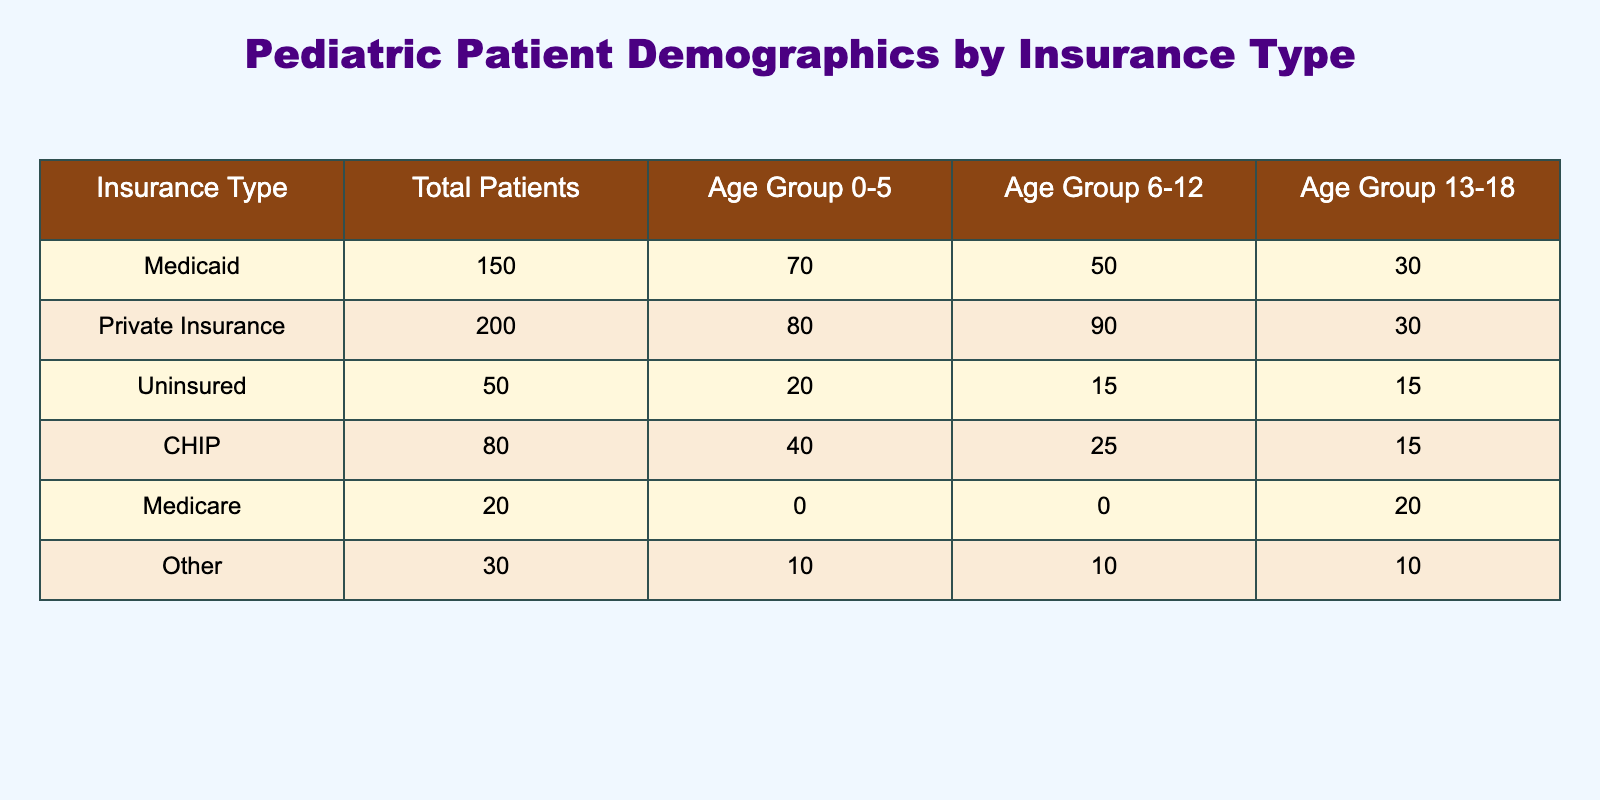What is the total number of patients with Private Insurance? The table shows the total number of patients for each insurance type. For Private Insurance, the total is listed directly as 200.
Answer: 200 Which age group has the highest number of patients insured by Medicaid? By examining the age group columns, Medicaid has 70 patients in the 0-5 age group, 50 in the 6-12 group, and 30 in the 13-18 group. The 0-5 age group has the highest number at 70.
Answer: 0-5 How many total patients are uninsured or have CHIP? To find this, we sum the total patients for both Uninsured (50) and CHIP (80). The calculation is 50 + 80 = 130.
Answer: 130 Is the number of patients with Medicare higher than those with Other insurance types? The table shows Medicare has 20 patients while Other has 30 patients. Therefore, the number of patients with Medicare (20) is not higher than Other (30).
Answer: No What is the average number of patients across all age groups for those insured by Private Insurance? Private Insurance has 80 patients in the 0-5 age group, 90 in 6-12, and 30 in 13-18. The total number across age groups is 80 + 90 + 30 = 200. To find the average, divide by the number of age groups (3): 200/3 ≈ 66.67.
Answer: 66.67 Which insurance type has the least number of patients in the 6-12 age group? Looking at the 6-12 age group, Medicaid has 50, Private Insurance has 90, Uninsured has 15, CHIP has 25, Medicare has 0, and Other has 10. Medicare has the lowest at 0 patients.
Answer: Medicare What percentage of the total patients are covered by Medicaid? To calculate this, first sum the total patients: 150 (Medicaid) + 200 (Private Insurance) + 50 (Uninsured) + 80 (CHIP) + 20 (Medicare) + 30 (Other) = 530. Then divide the number of Medicaid patients (150) by the total and multiply by 100: (150/530) * 100 ≈ 28.30%.
Answer: 28.30% Which age group accounts for the highest number of uninsured patients? For Uninsured patients, the age groups are 20 (0-5), 15 (6-12), and 15 (13-18). The 0-5 age group has the highest number with 20 patients.
Answer: 0-5 What is the total number of patients across all age groups with Other insurance? According to the table, Other has 10 patients each in the age groups 0-5, 6-12, and 13-18. Therefore, the total is 10 + 10 + 10 = 30.
Answer: 30 